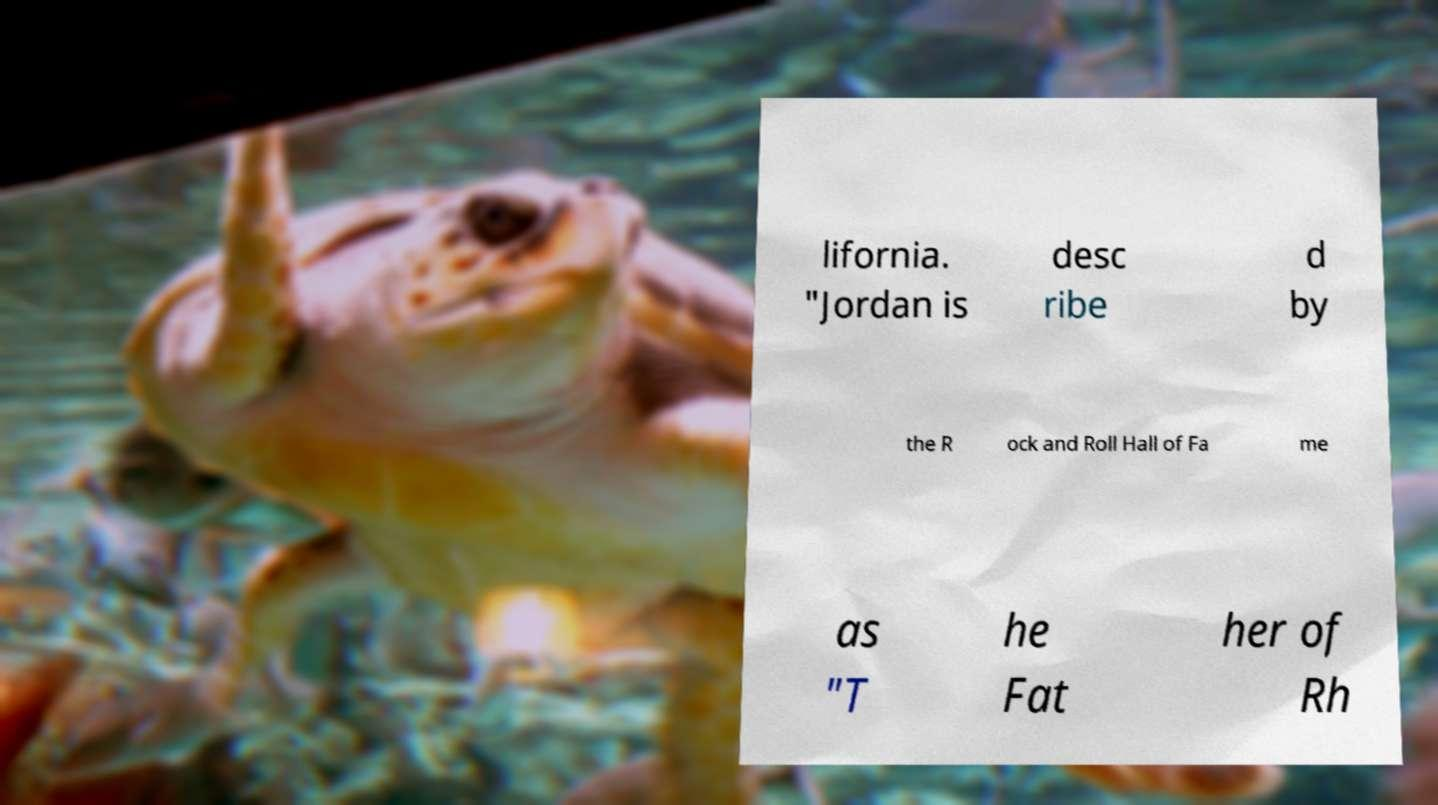Can you read and provide the text displayed in the image?This photo seems to have some interesting text. Can you extract and type it out for me? lifornia. "Jordan is desc ribe d by the R ock and Roll Hall of Fa me as "T he Fat her of Rh 